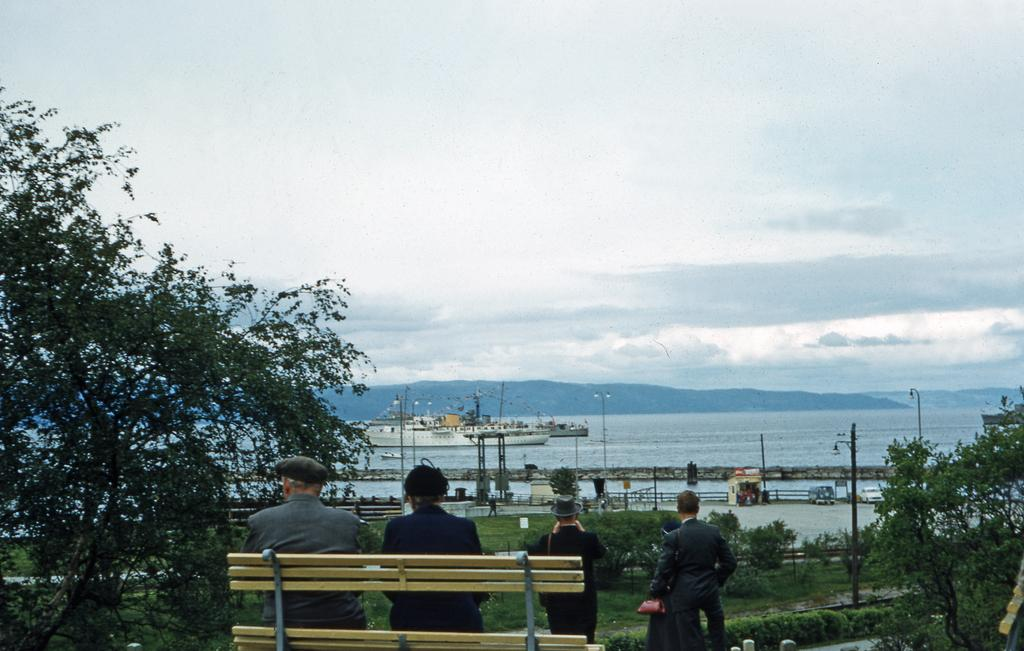What are the couple in the image doing? The couple is seated on a bench in the image. What are the people standing in the image doing? The facts do not specify what the people standing are doing. What can be seen in the background of the image? There is an ocean, ships, and trees visible in the image. How is the sky depicted in the image? The sky is blue and cloudy in the image. How many brains can be seen in the image? There are no brains visible in the image. Are there any beds present in the image? There is no mention of beds in the provided facts, and therefore, we cannot determine if any are present in the image. 